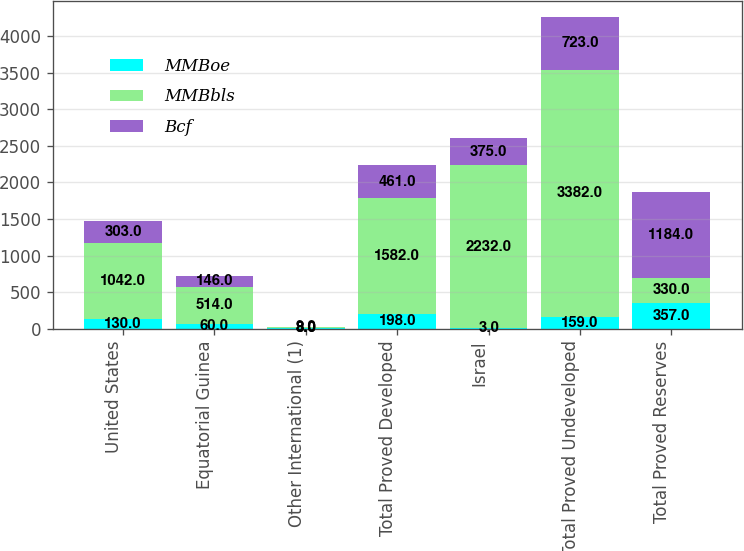<chart> <loc_0><loc_0><loc_500><loc_500><stacked_bar_chart><ecel><fcel>United States<fcel>Equatorial Guinea<fcel>Other International (1)<fcel>Total Proved Developed<fcel>Israel<fcel>Total Proved Undeveloped<fcel>Total Proved Reserves<nl><fcel>MMBoe<fcel>130<fcel>60<fcel>8<fcel>198<fcel>3<fcel>159<fcel>357<nl><fcel>MMBbls<fcel>1042<fcel>514<fcel>8<fcel>1582<fcel>2232<fcel>3382<fcel>330<nl><fcel>Bcf<fcel>303<fcel>146<fcel>9<fcel>461<fcel>375<fcel>723<fcel>1184<nl></chart> 